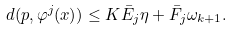Convert formula to latex. <formula><loc_0><loc_0><loc_500><loc_500>d ( p , \varphi ^ { j } ( x ) ) \leq K \bar { E } _ { j } \eta + \bar { F } _ { j } \omega _ { k + 1 } .</formula> 